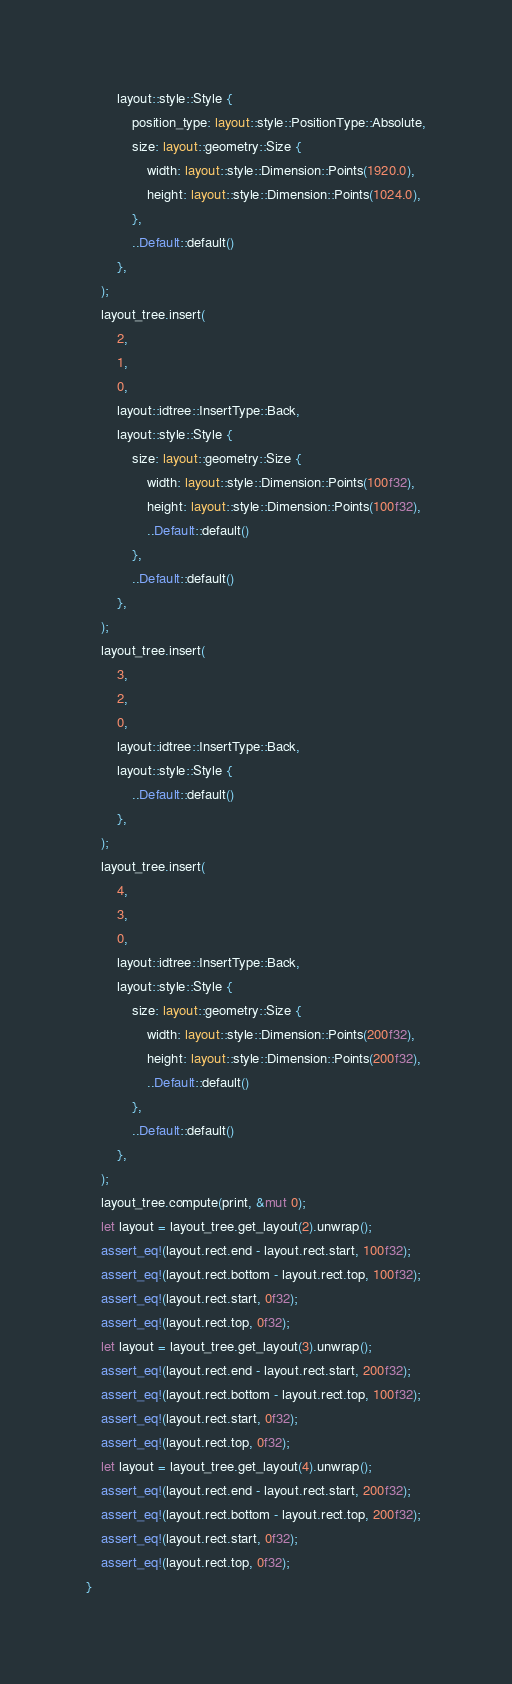<code> <loc_0><loc_0><loc_500><loc_500><_Rust_>        layout::style::Style {
            position_type: layout::style::PositionType::Absolute,
            size: layout::geometry::Size {
                width: layout::style::Dimension::Points(1920.0),
                height: layout::style::Dimension::Points(1024.0),
            },
            ..Default::default()
        },
    );
    layout_tree.insert(
        2,
        1,
        0,
        layout::idtree::InsertType::Back,
        layout::style::Style {
            size: layout::geometry::Size {
                width: layout::style::Dimension::Points(100f32),
                height: layout::style::Dimension::Points(100f32),
                ..Default::default()
            },
            ..Default::default()
        },
    );
    layout_tree.insert(
        3,
        2,
        0,
        layout::idtree::InsertType::Back,
        layout::style::Style {
            ..Default::default()
        },
    );
    layout_tree.insert(
        4,
        3,
        0,
        layout::idtree::InsertType::Back,
        layout::style::Style {
            size: layout::geometry::Size {
                width: layout::style::Dimension::Points(200f32),
                height: layout::style::Dimension::Points(200f32),
                ..Default::default()
            },
            ..Default::default()
        },
    );
    layout_tree.compute(print, &mut 0);
    let layout = layout_tree.get_layout(2).unwrap();
    assert_eq!(layout.rect.end - layout.rect.start, 100f32);
    assert_eq!(layout.rect.bottom - layout.rect.top, 100f32);
    assert_eq!(layout.rect.start, 0f32);
    assert_eq!(layout.rect.top, 0f32);
    let layout = layout_tree.get_layout(3).unwrap();
    assert_eq!(layout.rect.end - layout.rect.start, 200f32);
    assert_eq!(layout.rect.bottom - layout.rect.top, 100f32);
    assert_eq!(layout.rect.start, 0f32);
    assert_eq!(layout.rect.top, 0f32);
    let layout = layout_tree.get_layout(4).unwrap();
    assert_eq!(layout.rect.end - layout.rect.start, 200f32);
    assert_eq!(layout.rect.bottom - layout.rect.top, 200f32);
    assert_eq!(layout.rect.start, 0f32);
    assert_eq!(layout.rect.top, 0f32);
}
</code> 